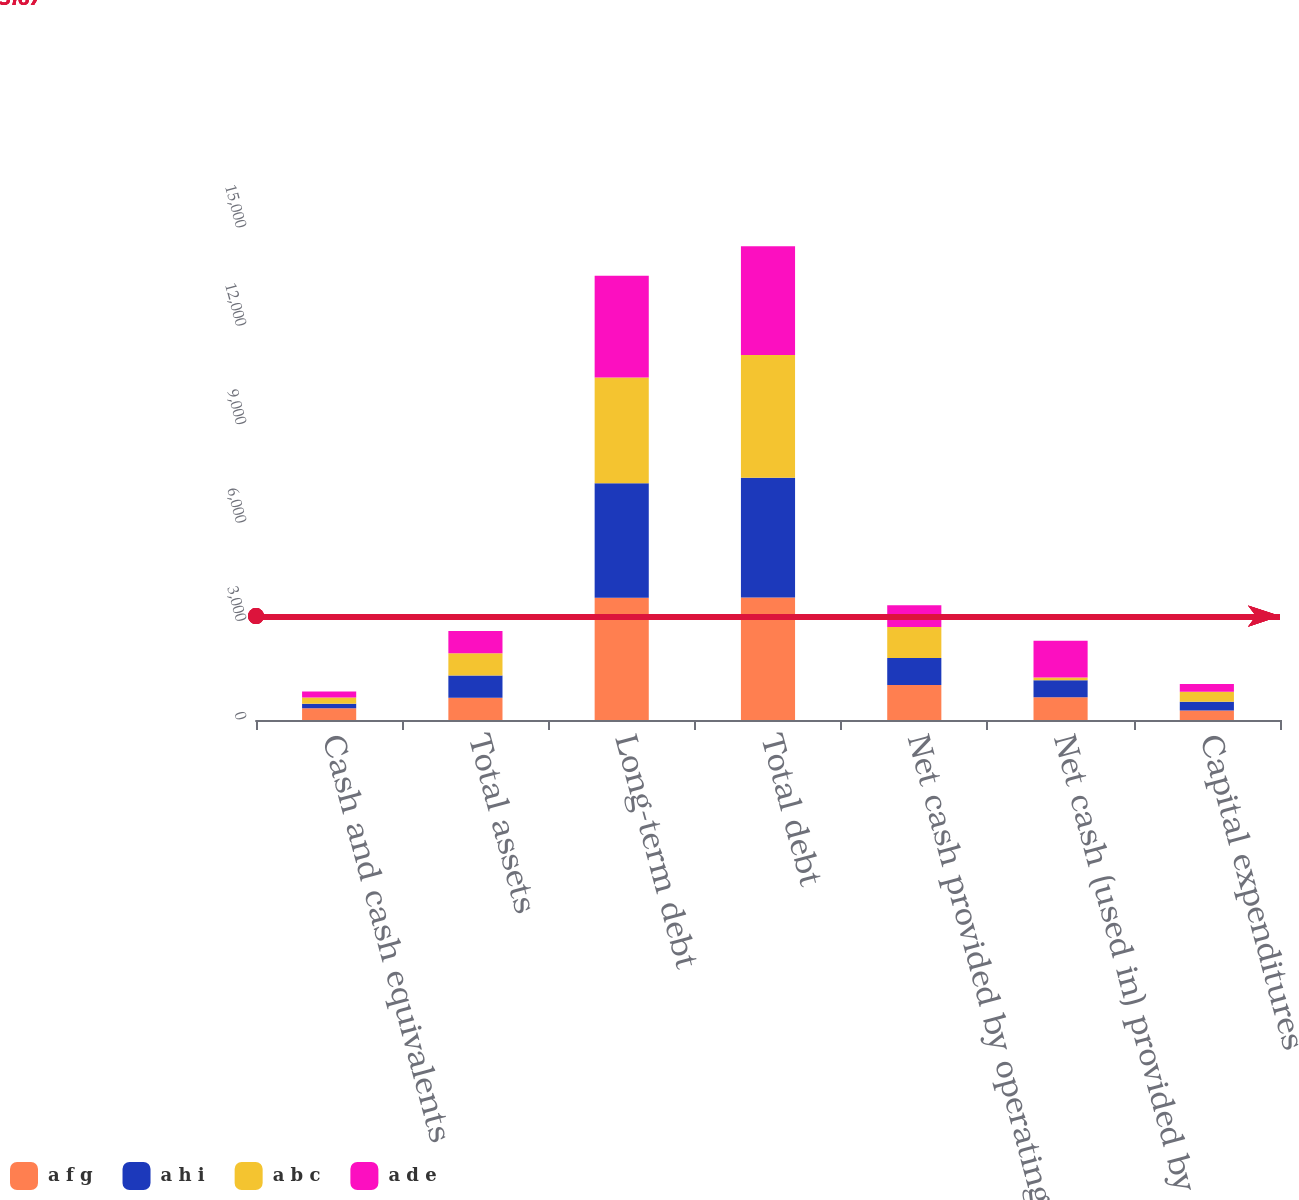Convert chart. <chart><loc_0><loc_0><loc_500><loc_500><stacked_bar_chart><ecel><fcel>Cash and cash equivalents<fcel>Total assets<fcel>Long-term debt<fcel>Total debt<fcel>Net cash provided by operating<fcel>Net cash (used in) provided by<fcel>Capital expenditures<nl><fcel>a f g<fcel>359<fcel>679<fcel>3728<fcel>3734<fcel>1069<fcel>691<fcel>293<nl><fcel>a h i<fcel>133<fcel>679<fcel>3492<fcel>3651<fcel>821<fcel>518<fcel>263<nl><fcel>a b c<fcel>192<fcel>679<fcel>3224<fcel>3742<fcel>944<fcel>86<fcel>308<nl><fcel>a d e<fcel>187<fcel>679<fcel>3102<fcel>3314<fcel>667<fcel>1121<fcel>231<nl></chart> 